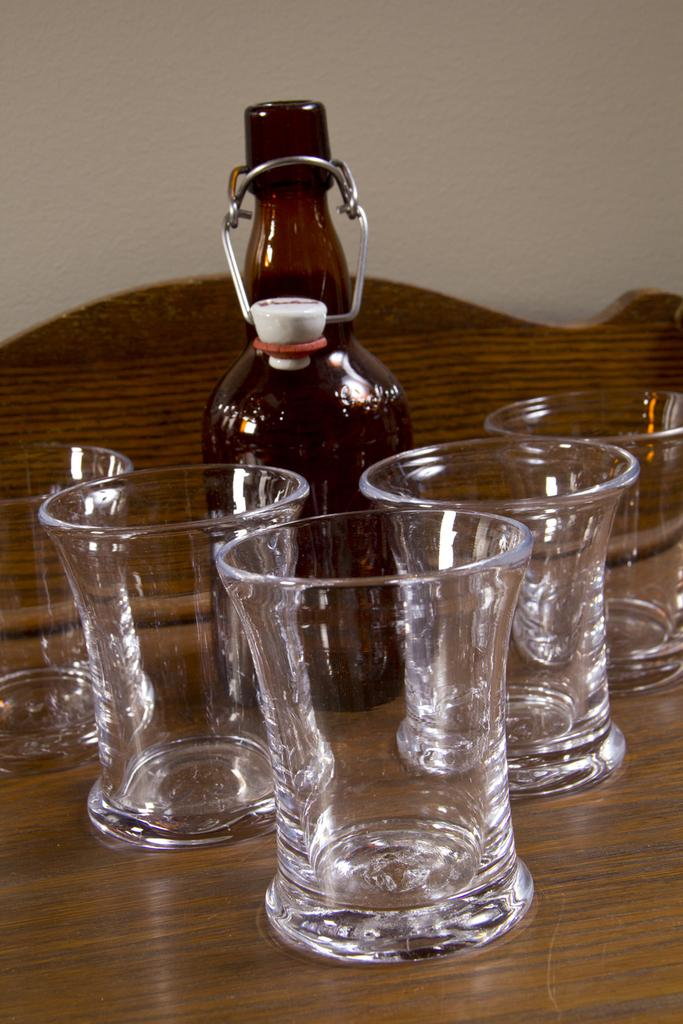What is one object that can be seen in the image? There is a bottle in the image. What else can be seen in the image besides the bottle? There are glasses in the image. How many tests are being conducted in the image? There is no indication of any tests being conducted in the image; it only shows a bottle and glasses. 